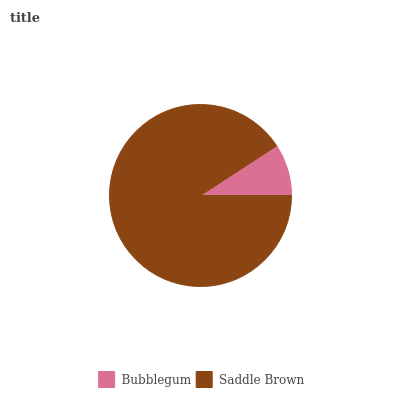Is Bubblegum the minimum?
Answer yes or no. Yes. Is Saddle Brown the maximum?
Answer yes or no. Yes. Is Saddle Brown the minimum?
Answer yes or no. No. Is Saddle Brown greater than Bubblegum?
Answer yes or no. Yes. Is Bubblegum less than Saddle Brown?
Answer yes or no. Yes. Is Bubblegum greater than Saddle Brown?
Answer yes or no. No. Is Saddle Brown less than Bubblegum?
Answer yes or no. No. Is Saddle Brown the high median?
Answer yes or no. Yes. Is Bubblegum the low median?
Answer yes or no. Yes. Is Bubblegum the high median?
Answer yes or no. No. Is Saddle Brown the low median?
Answer yes or no. No. 